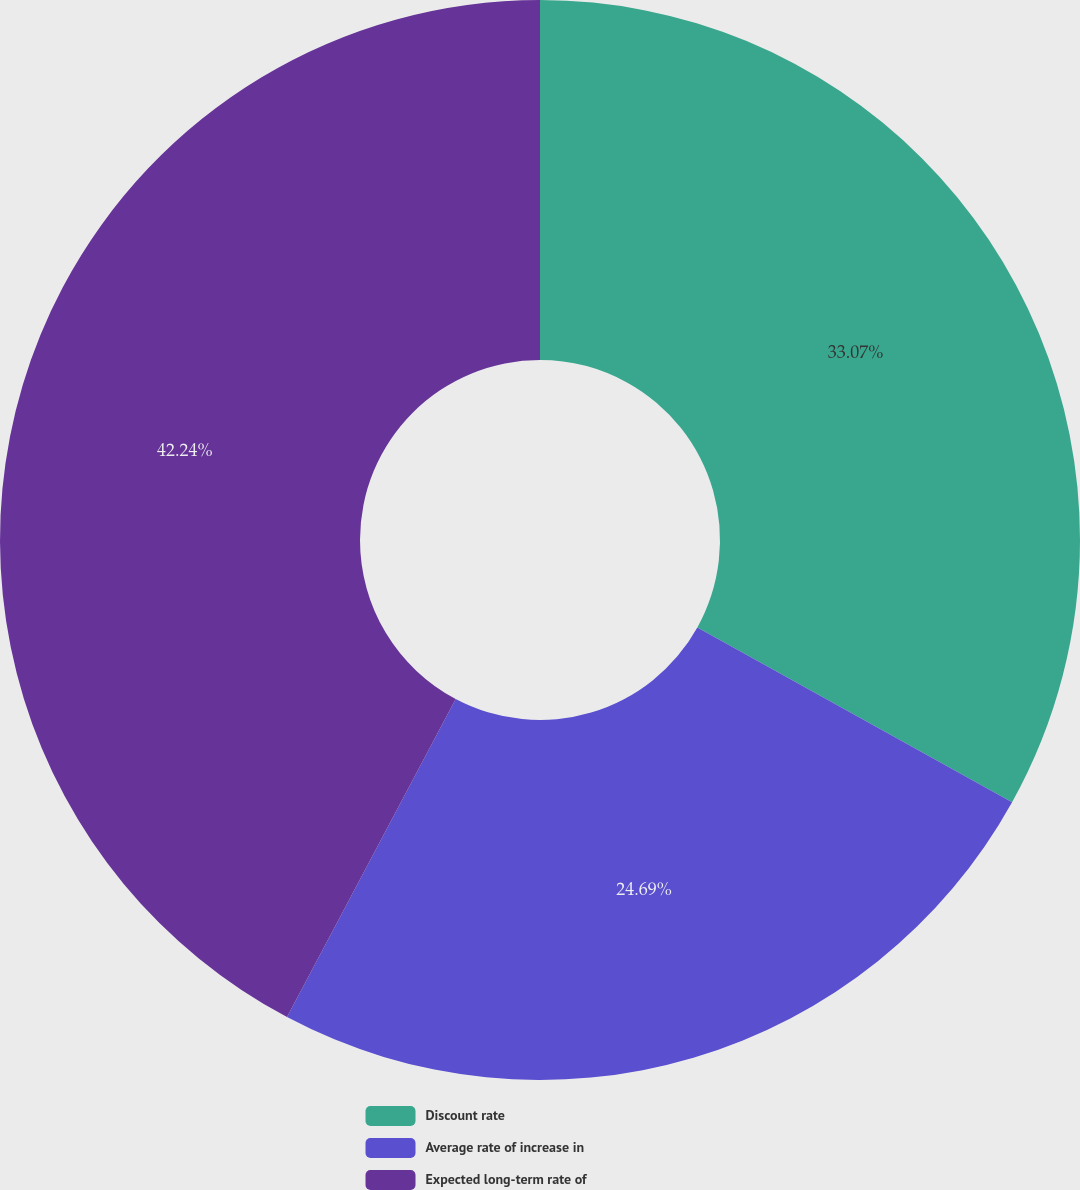<chart> <loc_0><loc_0><loc_500><loc_500><pie_chart><fcel>Discount rate<fcel>Average rate of increase in<fcel>Expected long-term rate of<nl><fcel>33.07%<fcel>24.69%<fcel>42.24%<nl></chart> 